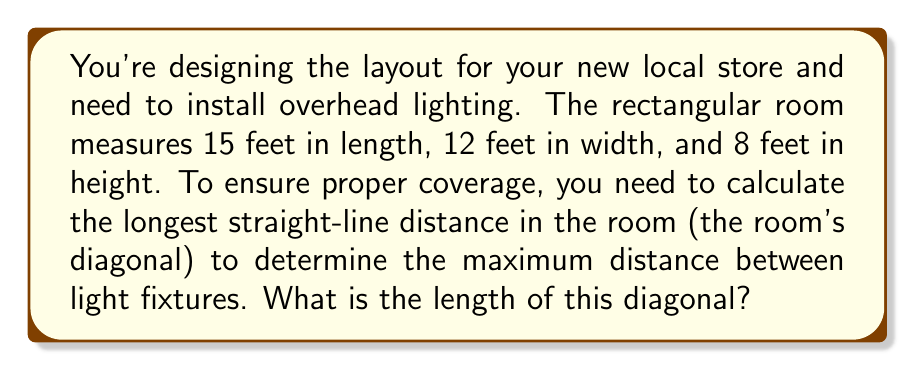Solve this math problem. To solve this problem, we'll use the three-dimensional extension of the Pythagorean theorem, also known as the distance formula in 3D space.

1) Let's define our variables:
   $l$ = length = 15 feet
   $w$ = width = 12 feet
   $h$ = height = 8 feet

2) The diagonal of a rectangular room can be calculated using the formula:

   $$d = \sqrt{l^2 + w^2 + h^2}$$

3) Let's substitute our values:

   $$d = \sqrt{15^2 + 12^2 + 8^2}$$

4) Simplify the squared terms:

   $$d = \sqrt{225 + 144 + 64}$$

5) Add the terms under the square root:

   $$d = \sqrt{433}$$

6) Calculate the square root:

   $$d \approx 20.81 \text{ feet}$$

[asy]
import three;

size(200);
currentprojection=perspective(6,3,2);

draw(box((0,0,0),(15,12,8)));
draw((0,0,0)--(15,12,8),red);

label("15'",(7.5,0,0),S);
label("12'",(15,6,0),E);
label("8'",(15,12,4),N);
label("d",(7.5,6,4),NW);
[/asy]
Answer: $20.81 \text{ feet}$ 